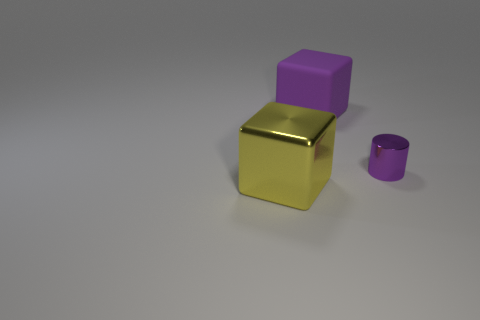How many other objects are there of the same color as the tiny cylinder?
Offer a terse response. 1. How many objects are on the left side of the purple cube and behind the small purple cylinder?
Keep it short and to the point. 0. Is there any other thing that is the same size as the purple metal thing?
Provide a short and direct response. No. Are there more rubber objects on the left side of the purple metallic object than large purple blocks that are right of the purple block?
Give a very brief answer. Yes. There is a big thing that is behind the big metallic cube; what is its material?
Offer a terse response. Rubber. Does the yellow shiny thing have the same shape as the metallic object that is on the right side of the yellow block?
Offer a very short reply. No. What number of small purple cylinders are behind the large block left of the big purple cube that is on the right side of the yellow metallic object?
Your answer should be compact. 1. What color is the large rubber object that is the same shape as the big metallic object?
Provide a succinct answer. Purple. Are there any other things that have the same shape as the small purple shiny object?
Provide a succinct answer. No. What number of cubes are large matte objects or big metal objects?
Ensure brevity in your answer.  2. 